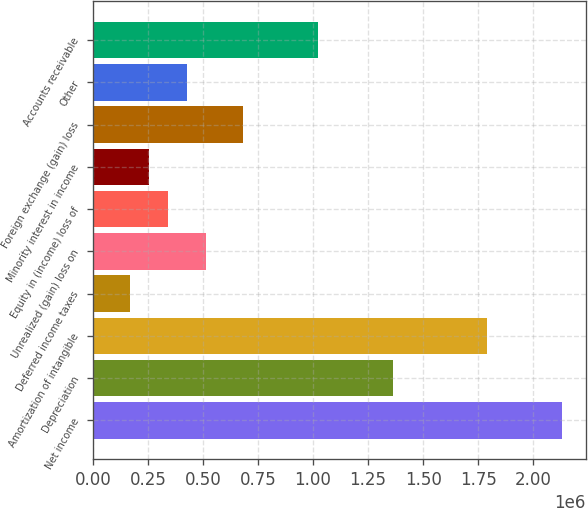Convert chart to OTSL. <chart><loc_0><loc_0><loc_500><loc_500><bar_chart><fcel>Net income<fcel>Depreciation<fcel>Amortization of intangible<fcel>Deferred income taxes<fcel>Unrealized (gain) loss on<fcel>Equity in (income) loss of<fcel>Minority interest in income<fcel>Foreign exchange (gain) loss<fcel>Other<fcel>Accounts receivable<nl><fcel>2.13192e+06<fcel>1.36473e+06<fcel>1.79095e+06<fcel>171330<fcel>512302<fcel>341816<fcel>256573<fcel>682788<fcel>427059<fcel>1.02376e+06<nl></chart> 